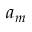<formula> <loc_0><loc_0><loc_500><loc_500>a _ { m }</formula> 